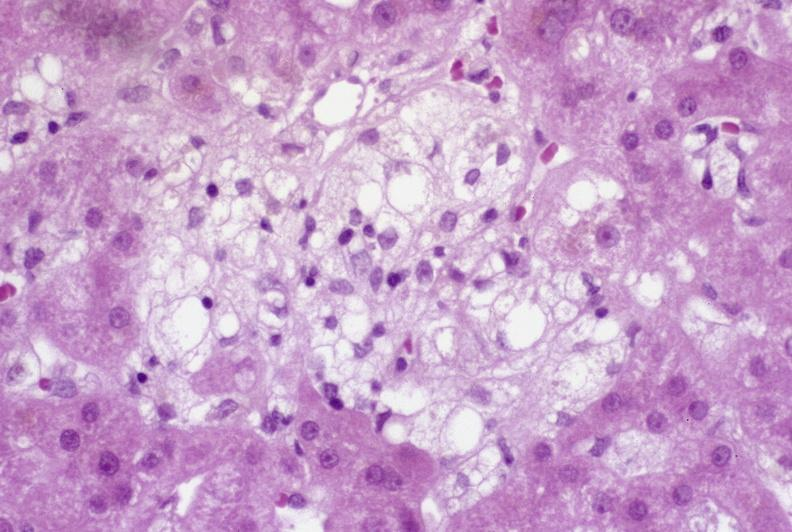s liver present?
Answer the question using a single word or phrase. Yes 